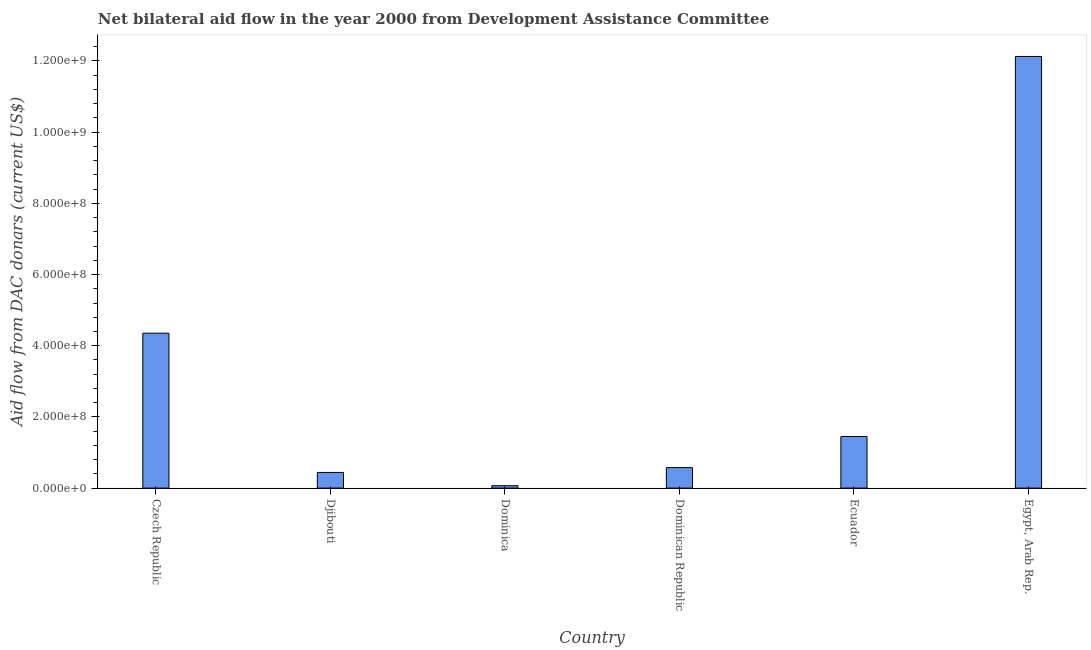What is the title of the graph?
Your response must be concise. Net bilateral aid flow in the year 2000 from Development Assistance Committee. What is the label or title of the Y-axis?
Offer a very short reply. Aid flow from DAC donars (current US$). What is the net bilateral aid flows from dac donors in Dominican Republic?
Give a very brief answer. 5.75e+07. Across all countries, what is the maximum net bilateral aid flows from dac donors?
Offer a terse response. 1.21e+09. Across all countries, what is the minimum net bilateral aid flows from dac donors?
Provide a succinct answer. 6.72e+06. In which country was the net bilateral aid flows from dac donors maximum?
Provide a succinct answer. Egypt, Arab Rep. In which country was the net bilateral aid flows from dac donors minimum?
Your response must be concise. Dominica. What is the sum of the net bilateral aid flows from dac donors?
Provide a succinct answer. 1.90e+09. What is the difference between the net bilateral aid flows from dac donors in Czech Republic and Dominican Republic?
Your answer should be compact. 3.78e+08. What is the average net bilateral aid flows from dac donors per country?
Your answer should be compact. 3.17e+08. What is the median net bilateral aid flows from dac donors?
Your answer should be compact. 1.01e+08. What is the ratio of the net bilateral aid flows from dac donors in Czech Republic to that in Djibouti?
Offer a very short reply. 9.9. Is the difference between the net bilateral aid flows from dac donors in Djibouti and Dominican Republic greater than the difference between any two countries?
Give a very brief answer. No. What is the difference between the highest and the second highest net bilateral aid flows from dac donors?
Offer a very short reply. 7.77e+08. Is the sum of the net bilateral aid flows from dac donors in Czech Republic and Dominica greater than the maximum net bilateral aid flows from dac donors across all countries?
Ensure brevity in your answer.  No. What is the difference between the highest and the lowest net bilateral aid flows from dac donors?
Offer a very short reply. 1.21e+09. In how many countries, is the net bilateral aid flows from dac donors greater than the average net bilateral aid flows from dac donors taken over all countries?
Offer a very short reply. 2. How many bars are there?
Provide a succinct answer. 6. Are all the bars in the graph horizontal?
Offer a terse response. No. How many countries are there in the graph?
Your response must be concise. 6. What is the difference between two consecutive major ticks on the Y-axis?
Offer a terse response. 2.00e+08. Are the values on the major ticks of Y-axis written in scientific E-notation?
Provide a succinct answer. Yes. What is the Aid flow from DAC donars (current US$) in Czech Republic?
Your response must be concise. 4.35e+08. What is the Aid flow from DAC donars (current US$) in Djibouti?
Your response must be concise. 4.40e+07. What is the Aid flow from DAC donars (current US$) of Dominica?
Your answer should be compact. 6.72e+06. What is the Aid flow from DAC donars (current US$) of Dominican Republic?
Offer a terse response. 5.75e+07. What is the Aid flow from DAC donars (current US$) in Ecuador?
Ensure brevity in your answer.  1.45e+08. What is the Aid flow from DAC donars (current US$) of Egypt, Arab Rep.?
Ensure brevity in your answer.  1.21e+09. What is the difference between the Aid flow from DAC donars (current US$) in Czech Republic and Djibouti?
Make the answer very short. 3.91e+08. What is the difference between the Aid flow from DAC donars (current US$) in Czech Republic and Dominica?
Make the answer very short. 4.28e+08. What is the difference between the Aid flow from DAC donars (current US$) in Czech Republic and Dominican Republic?
Your response must be concise. 3.78e+08. What is the difference between the Aid flow from DAC donars (current US$) in Czech Republic and Ecuador?
Give a very brief answer. 2.90e+08. What is the difference between the Aid flow from DAC donars (current US$) in Czech Republic and Egypt, Arab Rep.?
Your answer should be compact. -7.77e+08. What is the difference between the Aid flow from DAC donars (current US$) in Djibouti and Dominica?
Provide a short and direct response. 3.72e+07. What is the difference between the Aid flow from DAC donars (current US$) in Djibouti and Dominican Republic?
Your answer should be compact. -1.35e+07. What is the difference between the Aid flow from DAC donars (current US$) in Djibouti and Ecuador?
Provide a short and direct response. -1.01e+08. What is the difference between the Aid flow from DAC donars (current US$) in Djibouti and Egypt, Arab Rep.?
Your answer should be very brief. -1.17e+09. What is the difference between the Aid flow from DAC donars (current US$) in Dominica and Dominican Republic?
Offer a very short reply. -5.08e+07. What is the difference between the Aid flow from DAC donars (current US$) in Dominica and Ecuador?
Provide a short and direct response. -1.38e+08. What is the difference between the Aid flow from DAC donars (current US$) in Dominica and Egypt, Arab Rep.?
Make the answer very short. -1.21e+09. What is the difference between the Aid flow from DAC donars (current US$) in Dominican Republic and Ecuador?
Offer a terse response. -8.75e+07. What is the difference between the Aid flow from DAC donars (current US$) in Dominican Republic and Egypt, Arab Rep.?
Your answer should be compact. -1.16e+09. What is the difference between the Aid flow from DAC donars (current US$) in Ecuador and Egypt, Arab Rep.?
Your response must be concise. -1.07e+09. What is the ratio of the Aid flow from DAC donars (current US$) in Czech Republic to that in Djibouti?
Your answer should be very brief. 9.9. What is the ratio of the Aid flow from DAC donars (current US$) in Czech Republic to that in Dominica?
Your answer should be very brief. 64.77. What is the ratio of the Aid flow from DAC donars (current US$) in Czech Republic to that in Dominican Republic?
Your answer should be compact. 7.57. What is the ratio of the Aid flow from DAC donars (current US$) in Czech Republic to that in Ecuador?
Give a very brief answer. 3. What is the ratio of the Aid flow from DAC donars (current US$) in Czech Republic to that in Egypt, Arab Rep.?
Give a very brief answer. 0.36. What is the ratio of the Aid flow from DAC donars (current US$) in Djibouti to that in Dominica?
Provide a short and direct response. 6.54. What is the ratio of the Aid flow from DAC donars (current US$) in Djibouti to that in Dominican Republic?
Provide a succinct answer. 0.77. What is the ratio of the Aid flow from DAC donars (current US$) in Djibouti to that in Ecuador?
Your answer should be very brief. 0.3. What is the ratio of the Aid flow from DAC donars (current US$) in Djibouti to that in Egypt, Arab Rep.?
Offer a terse response. 0.04. What is the ratio of the Aid flow from DAC donars (current US$) in Dominica to that in Dominican Republic?
Ensure brevity in your answer.  0.12. What is the ratio of the Aid flow from DAC donars (current US$) in Dominica to that in Ecuador?
Your response must be concise. 0.05. What is the ratio of the Aid flow from DAC donars (current US$) in Dominica to that in Egypt, Arab Rep.?
Ensure brevity in your answer.  0.01. What is the ratio of the Aid flow from DAC donars (current US$) in Dominican Republic to that in Ecuador?
Your answer should be compact. 0.4. What is the ratio of the Aid flow from DAC donars (current US$) in Dominican Republic to that in Egypt, Arab Rep.?
Your response must be concise. 0.05. What is the ratio of the Aid flow from DAC donars (current US$) in Ecuador to that in Egypt, Arab Rep.?
Give a very brief answer. 0.12. 